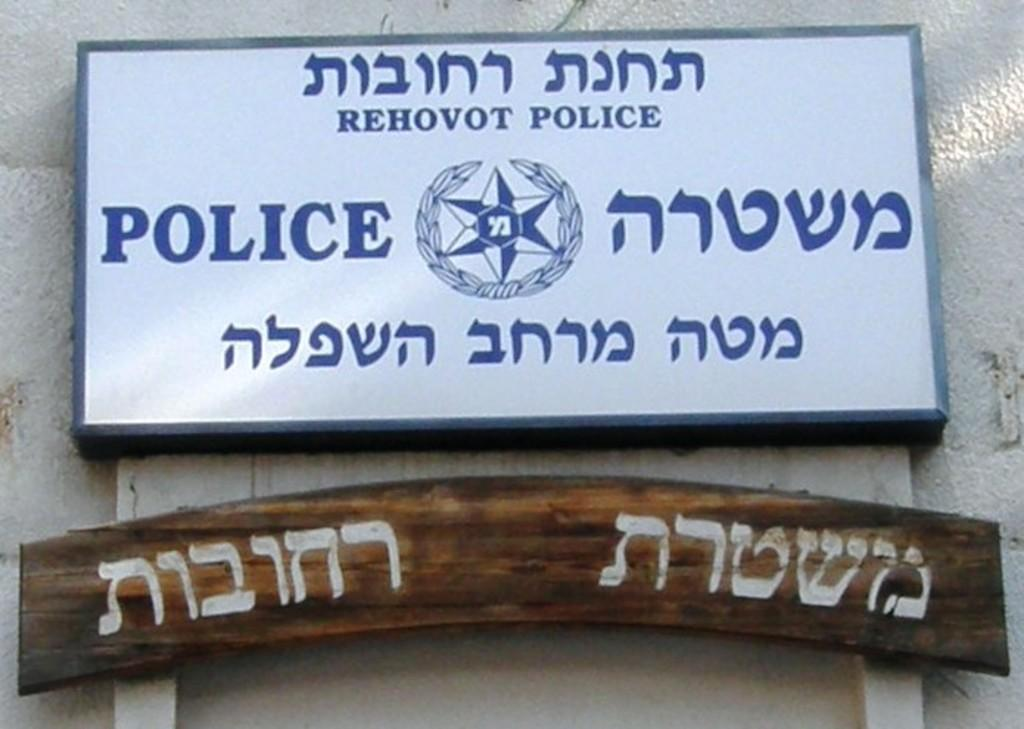Provide a one-sentence caption for the provided image. A sign in Hebrew for the Rehovot Police. 